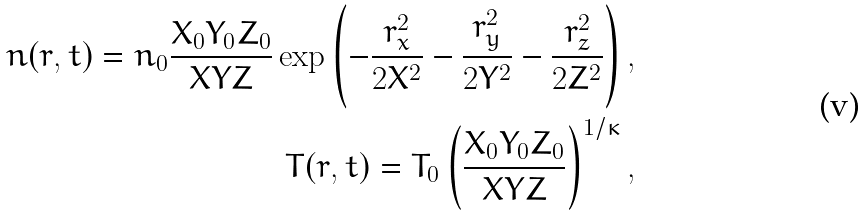Convert formula to latex. <formula><loc_0><loc_0><loc_500><loc_500>n ( r , t ) = n _ { 0 } \frac { X _ { 0 } Y _ { 0 } Z _ { 0 } } { X Y Z } \exp \left ( - \frac { r _ { x } ^ { 2 } } { 2 X ^ { 2 } } - \frac { r _ { y } ^ { 2 } } { 2 Y ^ { 2 } } - \frac { r _ { z } ^ { 2 } } { 2 Z ^ { 2 } } \right ) , \\ T ( r , t ) = T _ { 0 } \left ( \frac { X _ { 0 } Y _ { 0 } Z _ { 0 } } { X Y Z } \right ) ^ { 1 / \kappa } ,</formula> 